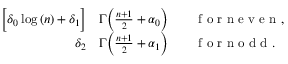Convert formula to latex. <formula><loc_0><loc_0><loc_500><loc_500>\begin{array} { r l } { \left [ \delta _ { 0 } \log { ( n ) } + \delta _ { 1 } \right ] } & \Gamma \left ( \frac { n + 1 } { 2 } + \alpha _ { 0 } \right ) \quad f o r n e v e n , } \\ { \delta _ { 2 } } & \Gamma \left ( \frac { n + 1 } { 2 } + \alpha _ { 1 } \right ) \quad f o r n o d d . } \end{array}</formula> 